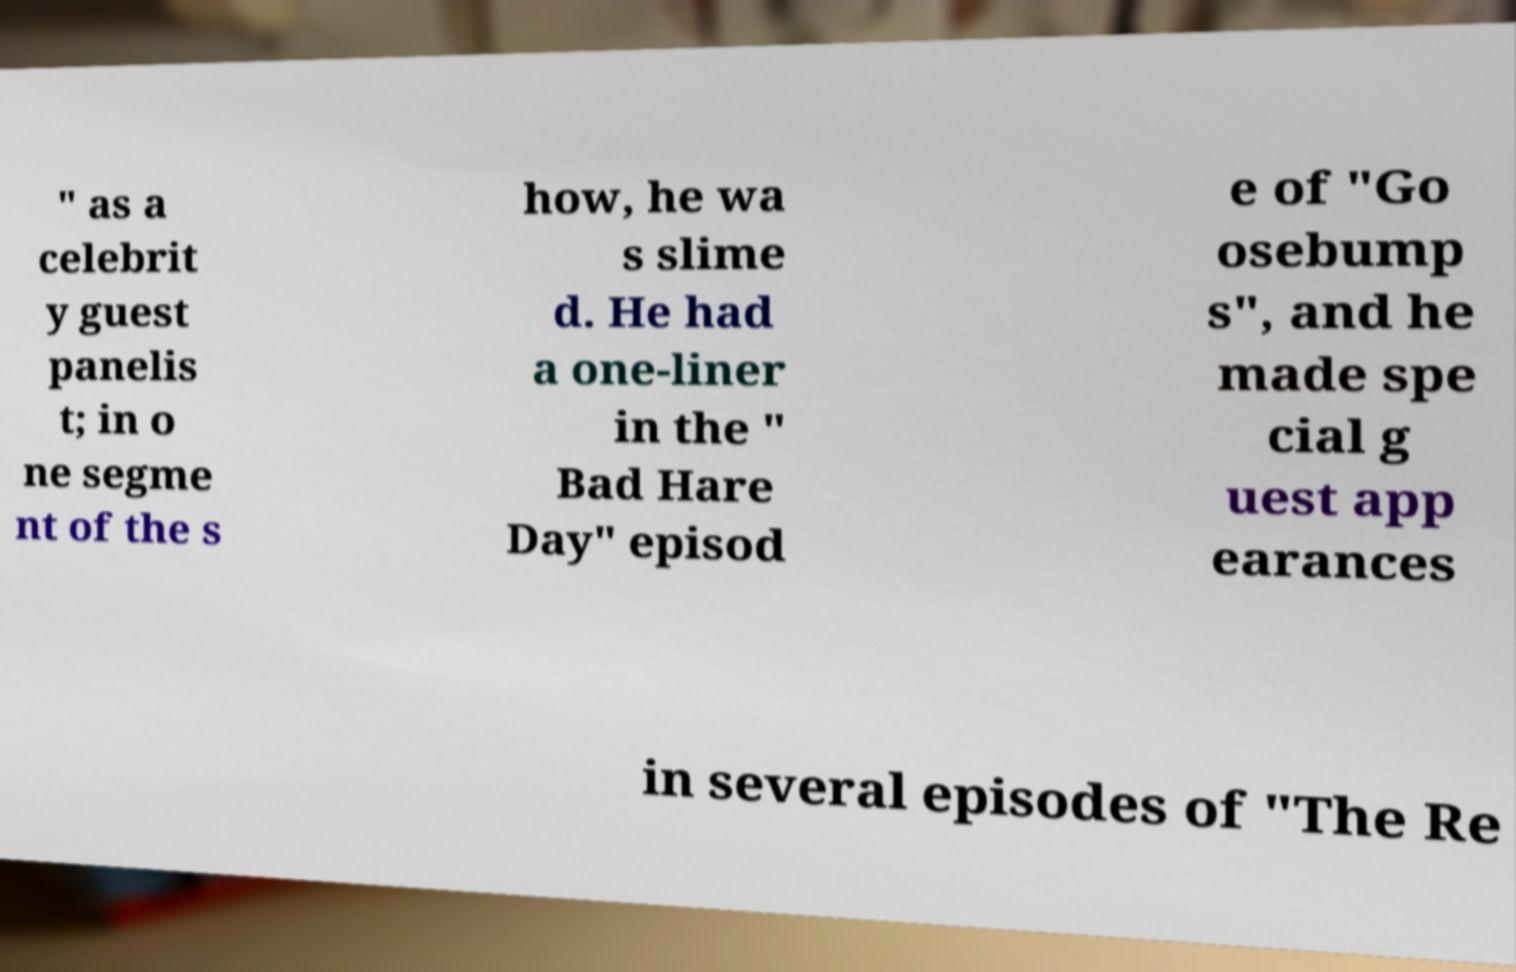What messages or text are displayed in this image? I need them in a readable, typed format. " as a celebrit y guest panelis t; in o ne segme nt of the s how, he wa s slime d. He had a one-liner in the " Bad Hare Day" episod e of "Go osebump s", and he made spe cial g uest app earances in several episodes of "The Re 